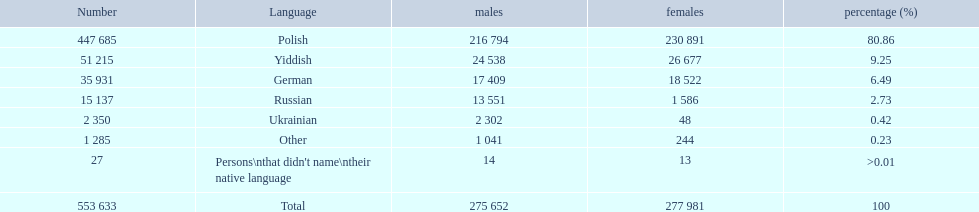What are all of the languages? Polish, Yiddish, German, Russian, Ukrainian, Other, Persons\nthat didn't name\ntheir native language. And how many people speak these languages? 447 685, 51 215, 35 931, 15 137, 2 350, 1 285, 27. Which language is used by most people? Polish. 